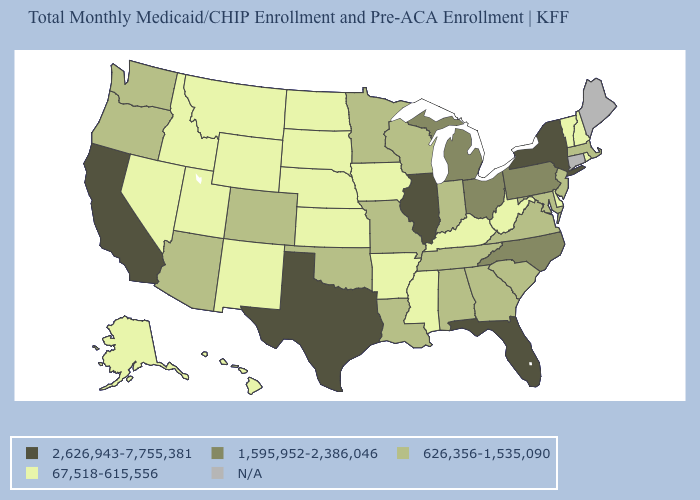What is the highest value in the USA?
Quick response, please. 2,626,943-7,755,381. How many symbols are there in the legend?
Quick response, please. 5. What is the value of Ohio?
Give a very brief answer. 1,595,952-2,386,046. What is the highest value in the USA?
Quick response, please. 2,626,943-7,755,381. Which states have the highest value in the USA?
Quick response, please. California, Florida, Illinois, New York, Texas. Which states have the highest value in the USA?
Answer briefly. California, Florida, Illinois, New York, Texas. Is the legend a continuous bar?
Give a very brief answer. No. What is the lowest value in the USA?
Give a very brief answer. 67,518-615,556. Which states have the lowest value in the USA?
Answer briefly. Alaska, Arkansas, Delaware, Hawaii, Idaho, Iowa, Kansas, Kentucky, Mississippi, Montana, Nebraska, Nevada, New Hampshire, New Mexico, North Dakota, Rhode Island, South Dakota, Utah, Vermont, West Virginia, Wyoming. What is the value of Rhode Island?
Give a very brief answer. 67,518-615,556. Name the states that have a value in the range 2,626,943-7,755,381?
Give a very brief answer. California, Florida, Illinois, New York, Texas. Name the states that have a value in the range 67,518-615,556?
Be succinct. Alaska, Arkansas, Delaware, Hawaii, Idaho, Iowa, Kansas, Kentucky, Mississippi, Montana, Nebraska, Nevada, New Hampshire, New Mexico, North Dakota, Rhode Island, South Dakota, Utah, Vermont, West Virginia, Wyoming. Name the states that have a value in the range 67,518-615,556?
Short answer required. Alaska, Arkansas, Delaware, Hawaii, Idaho, Iowa, Kansas, Kentucky, Mississippi, Montana, Nebraska, Nevada, New Hampshire, New Mexico, North Dakota, Rhode Island, South Dakota, Utah, Vermont, West Virginia, Wyoming. Does Georgia have the lowest value in the USA?
Concise answer only. No. 